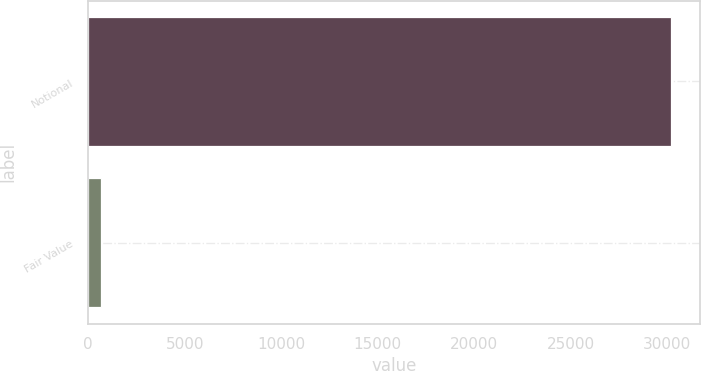<chart> <loc_0><loc_0><loc_500><loc_500><bar_chart><fcel>Notional<fcel>Fair Value<nl><fcel>30164<fcel>692<nl></chart> 